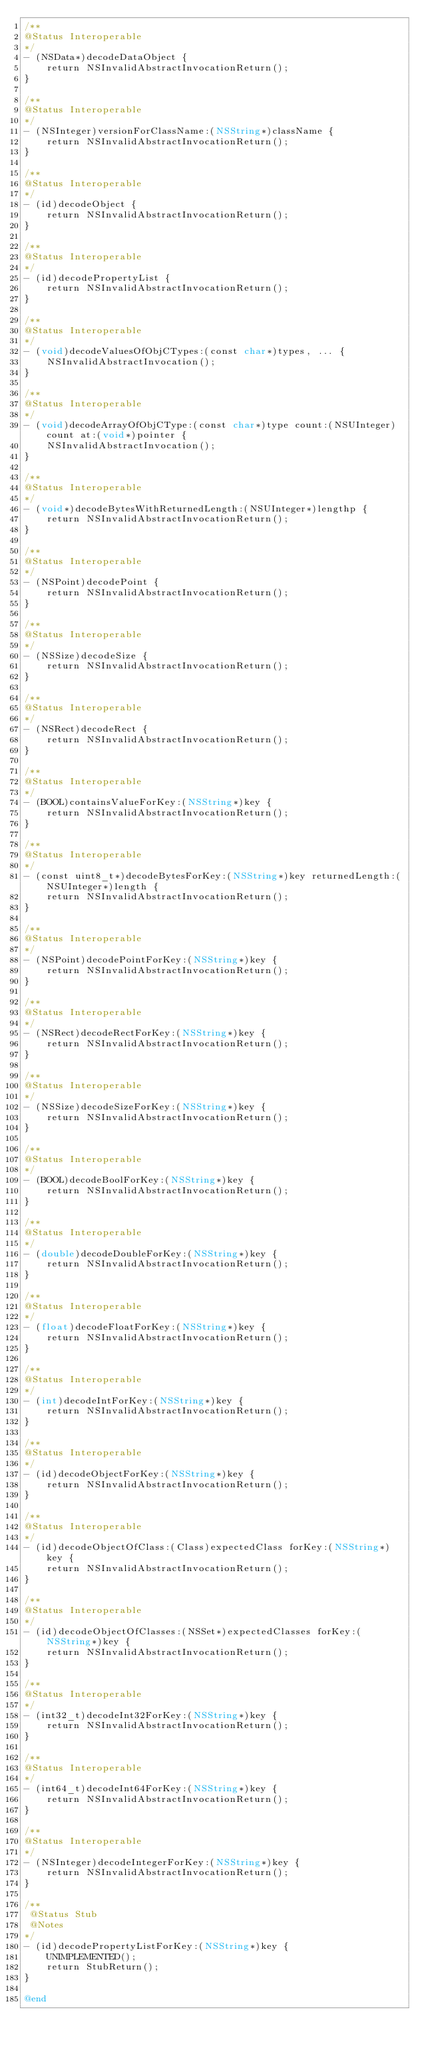Convert code to text. <code><loc_0><loc_0><loc_500><loc_500><_ObjectiveC_>/**
@Status Interoperable
*/
- (NSData*)decodeDataObject {
    return NSInvalidAbstractInvocationReturn();
}

/**
@Status Interoperable
*/
- (NSInteger)versionForClassName:(NSString*)className {
    return NSInvalidAbstractInvocationReturn();
}

/**
@Status Interoperable
*/
- (id)decodeObject {
    return NSInvalidAbstractInvocationReturn();
}

/**
@Status Interoperable
*/
- (id)decodePropertyList {
    return NSInvalidAbstractInvocationReturn();
}

/**
@Status Interoperable
*/
- (void)decodeValuesOfObjCTypes:(const char*)types, ... {
    NSInvalidAbstractInvocation();
}

/**
@Status Interoperable
*/
- (void)decodeArrayOfObjCType:(const char*)type count:(NSUInteger)count at:(void*)pointer {
    NSInvalidAbstractInvocation();
}

/**
@Status Interoperable
*/
- (void*)decodeBytesWithReturnedLength:(NSUInteger*)lengthp {
    return NSInvalidAbstractInvocationReturn();
}

/**
@Status Interoperable
*/
- (NSPoint)decodePoint {
    return NSInvalidAbstractInvocationReturn();
}

/**
@Status Interoperable
*/
- (NSSize)decodeSize {
    return NSInvalidAbstractInvocationReturn();
}

/**
@Status Interoperable
*/
- (NSRect)decodeRect {
    return NSInvalidAbstractInvocationReturn();
}

/**
@Status Interoperable
*/
- (BOOL)containsValueForKey:(NSString*)key {
    return NSInvalidAbstractInvocationReturn();
}

/**
@Status Interoperable
*/
- (const uint8_t*)decodeBytesForKey:(NSString*)key returnedLength:(NSUInteger*)length {
    return NSInvalidAbstractInvocationReturn();
}

/**
@Status Interoperable
*/
- (NSPoint)decodePointForKey:(NSString*)key {
    return NSInvalidAbstractInvocationReturn();
}

/**
@Status Interoperable
*/
- (NSRect)decodeRectForKey:(NSString*)key {
    return NSInvalidAbstractInvocationReturn();
}

/**
@Status Interoperable
*/
- (NSSize)decodeSizeForKey:(NSString*)key {
    return NSInvalidAbstractInvocationReturn();
}

/**
@Status Interoperable
*/
- (BOOL)decodeBoolForKey:(NSString*)key {
    return NSInvalidAbstractInvocationReturn();
}

/**
@Status Interoperable
*/
- (double)decodeDoubleForKey:(NSString*)key {
    return NSInvalidAbstractInvocationReturn();
}

/**
@Status Interoperable
*/
- (float)decodeFloatForKey:(NSString*)key {
    return NSInvalidAbstractInvocationReturn();
}

/**
@Status Interoperable
*/
- (int)decodeIntForKey:(NSString*)key {
    return NSInvalidAbstractInvocationReturn();
}

/**
@Status Interoperable
*/
- (id)decodeObjectForKey:(NSString*)key {
    return NSInvalidAbstractInvocationReturn();
}

/**
@Status Interoperable
*/
- (id)decodeObjectOfClass:(Class)expectedClass forKey:(NSString*)key {
    return NSInvalidAbstractInvocationReturn();
}

/**
@Status Interoperable
*/
- (id)decodeObjectOfClasses:(NSSet*)expectedClasses forKey:(NSString*)key {
    return NSInvalidAbstractInvocationReturn();
}

/**
@Status Interoperable
*/
- (int32_t)decodeInt32ForKey:(NSString*)key {
    return NSInvalidAbstractInvocationReturn();
}

/**
@Status Interoperable
*/
- (int64_t)decodeInt64ForKey:(NSString*)key {
    return NSInvalidAbstractInvocationReturn();
}

/**
@Status Interoperable
*/
- (NSInteger)decodeIntegerForKey:(NSString*)key {
    return NSInvalidAbstractInvocationReturn();
}

/**
 @Status Stub
 @Notes
*/
- (id)decodePropertyListForKey:(NSString*)key {
    UNIMPLEMENTED();
    return StubReturn();
}

@end


</code> 